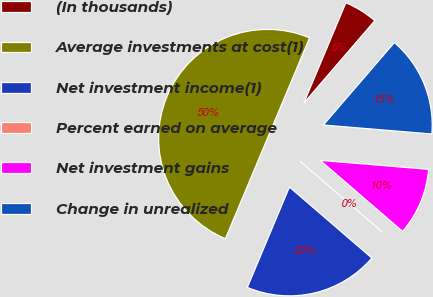Convert chart to OTSL. <chart><loc_0><loc_0><loc_500><loc_500><pie_chart><fcel>(In thousands)<fcel>Average investments at cost(1)<fcel>Net investment income(1)<fcel>Percent earned on average<fcel>Net investment gains<fcel>Change in unrealized<nl><fcel>5.0%<fcel>50.0%<fcel>20.0%<fcel>0.0%<fcel>10.0%<fcel>15.0%<nl></chart> 